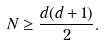Convert formula to latex. <formula><loc_0><loc_0><loc_500><loc_500>N \geq \frac { d ( d + 1 ) } { 2 } .</formula> 